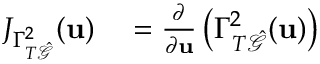<formula> <loc_0><loc_0><loc_500><loc_500>\begin{array} { r l } { J _ { \Gamma _ { T \hat { \mathcal { G } } } ^ { 2 } } ( u ) } & = \frac { \partial } { \partial u } \left ( \Gamma _ { T \hat { \mathcal { G } } } ^ { 2 } ( u ) \right ) } \end{array}</formula> 